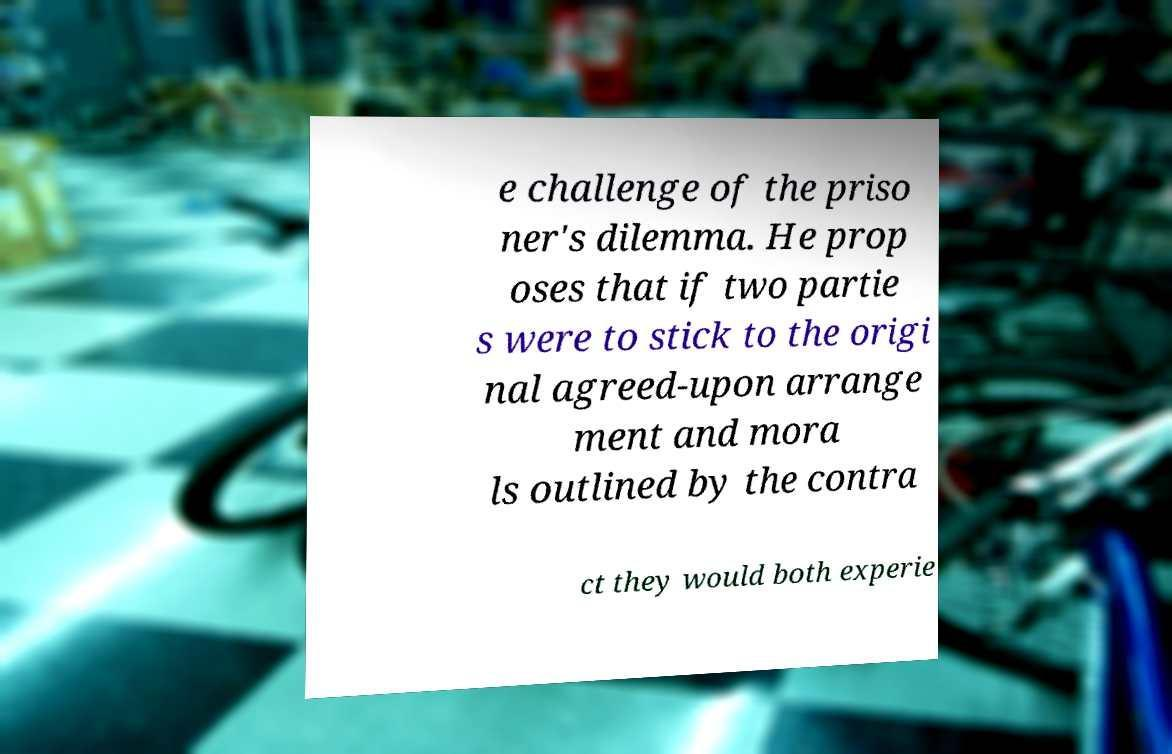I need the written content from this picture converted into text. Can you do that? e challenge of the priso ner's dilemma. He prop oses that if two partie s were to stick to the origi nal agreed-upon arrange ment and mora ls outlined by the contra ct they would both experie 